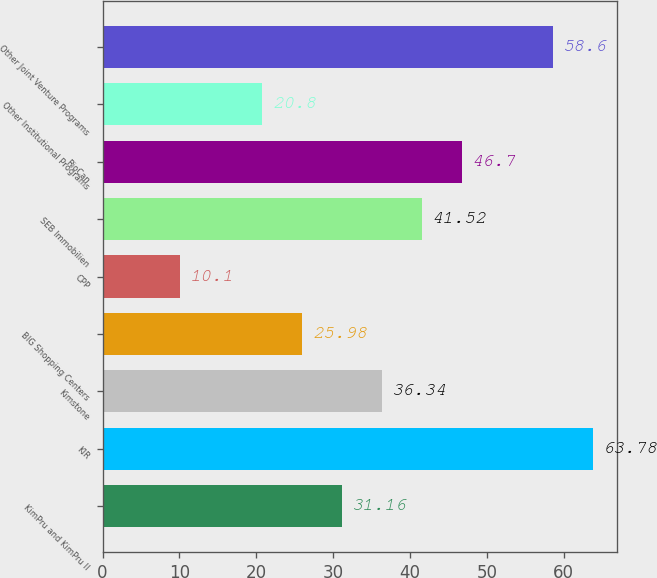Convert chart to OTSL. <chart><loc_0><loc_0><loc_500><loc_500><bar_chart><fcel>KimPru and KimPru II<fcel>KIR<fcel>Kimstone<fcel>BIG Shopping Centers<fcel>CPP<fcel>SEB Immobilien<fcel>RioCan<fcel>Other Institutional Programs<fcel>Other Joint Venture Programs<nl><fcel>31.16<fcel>63.78<fcel>36.34<fcel>25.98<fcel>10.1<fcel>41.52<fcel>46.7<fcel>20.8<fcel>58.6<nl></chart> 